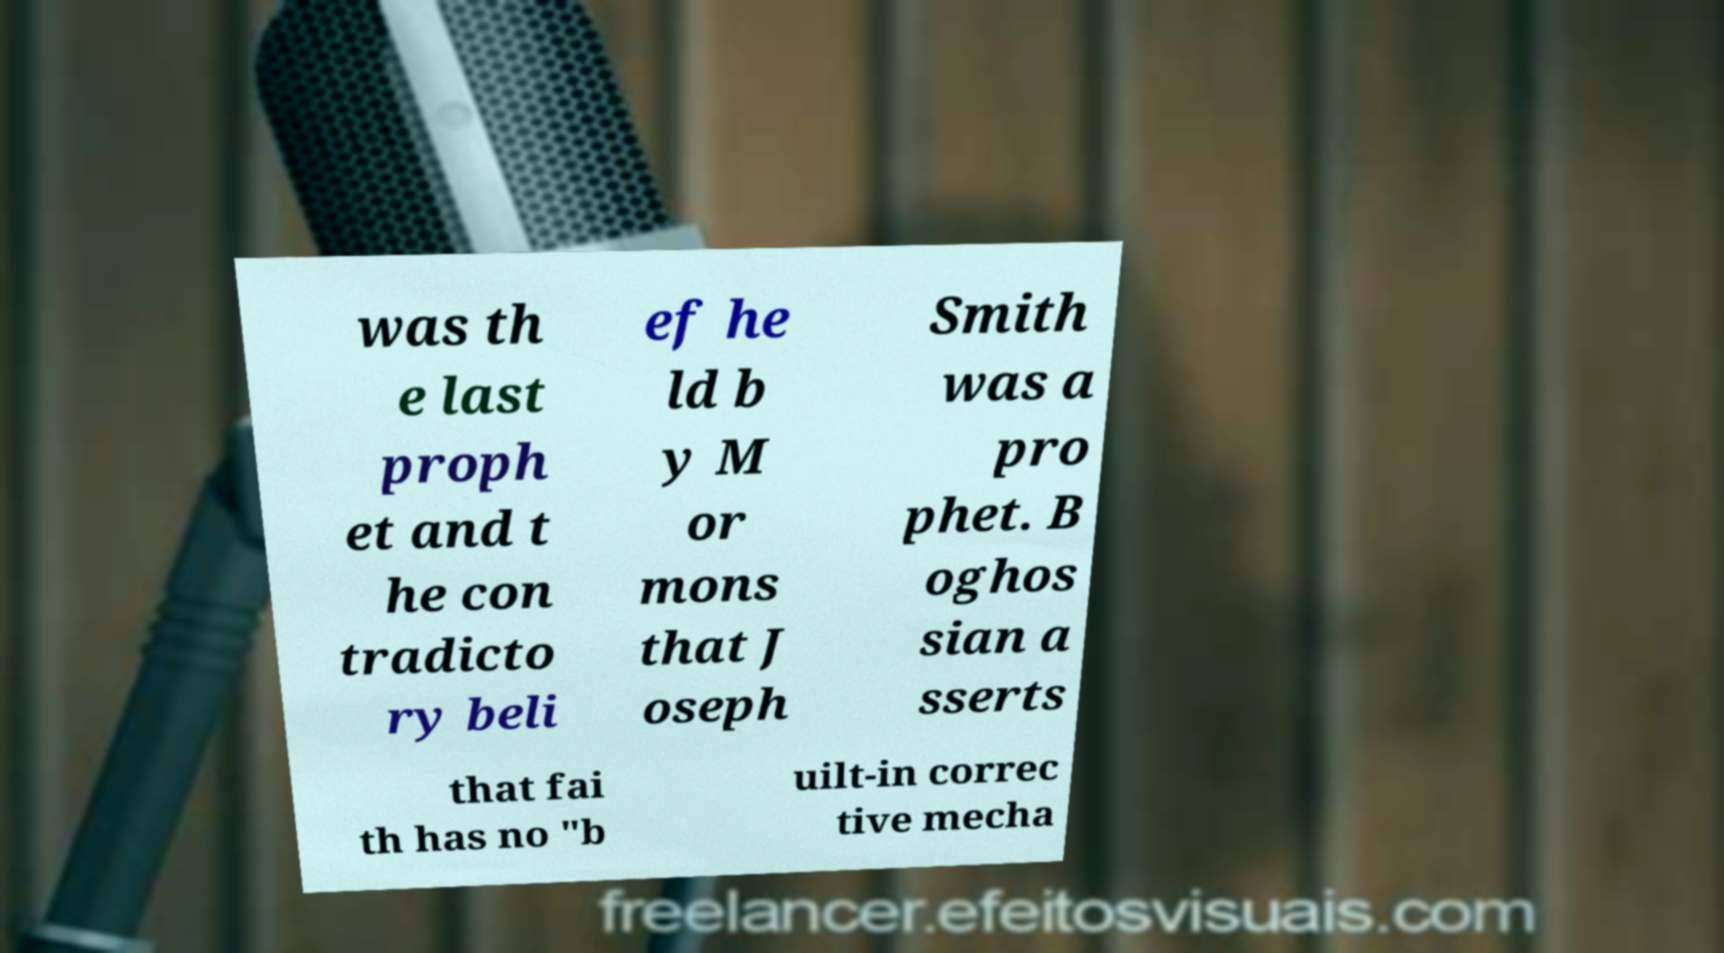Can you accurately transcribe the text from the provided image for me? was th e last proph et and t he con tradicto ry beli ef he ld b y M or mons that J oseph Smith was a pro phet. B oghos sian a sserts that fai th has no "b uilt-in correc tive mecha 